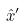Convert formula to latex. <formula><loc_0><loc_0><loc_500><loc_500>\hat { x } ^ { \prime }</formula> 